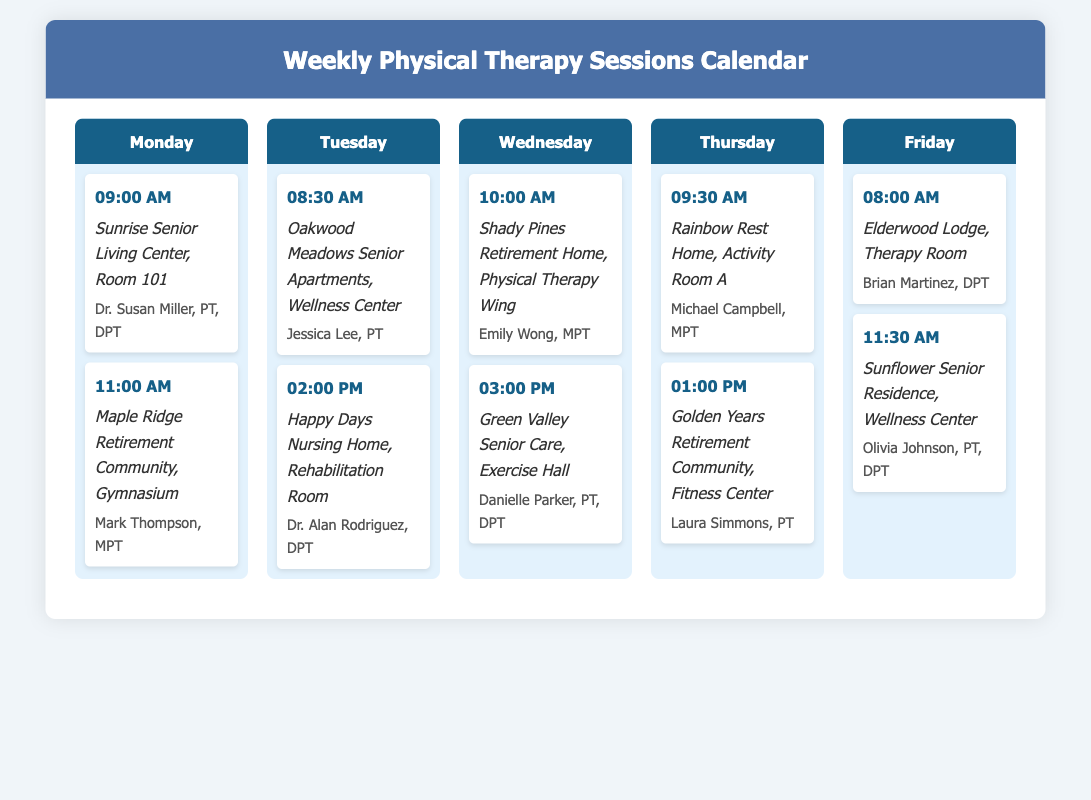What time is the first session on Monday? The first session time on Monday is mentioned in the document as the first listed time under Monday.
Answer: 09:00 AM Who is the therapist for the session at Happy Days Nursing Home on Tuesday? The therapist's name is found listed under the Tuesday section for the Happy Days Nursing Home session.
Answer: Dr. Alan Rodriguez Where is the physical therapy session on Thursday held? The location for the Thursday session is specified with two different locations. The first session's location is identified first in the Thursday section.
Answer: Rainbow Rest Home, Activity Room A How many sessions are scheduled on Wednesday? The number of sessions can be determined by counting the listed sessions under the Wednesday section.
Answer: 2 Which therapist has a session at the Golden Years Retirement Community? The therapist's name is included in the Thursday sessions at the specified location.
Answer: Laura Simmons What is the latest session time on Friday? The latest session time can be identified as the last listed time under Friday.
Answer: 11:30 AM On which day is the session at Shady Pines Retirement Home? The specific day of the session is mentioned in the title of the section that includes the location Shady Pines Retirement Home.
Answer: Wednesday What room is the session at Sunrise Senior Living Center held in? The document specifies the room for the session at Sunrise Senior Living Center.
Answer: Room 101 How many therapists are listed for Monday sessions? This can be determined by counting the unique therapist names under the Monday section.
Answer: 2 